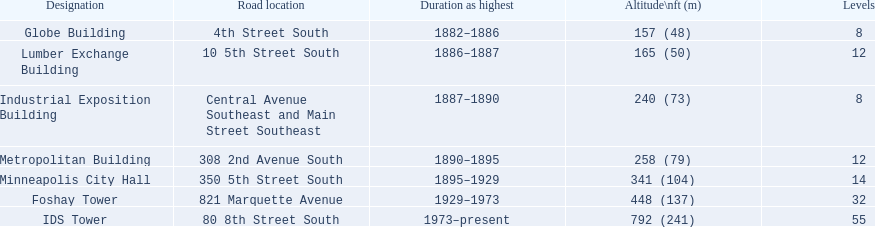How many buildings on the list are taller than 200 feet? 5. 